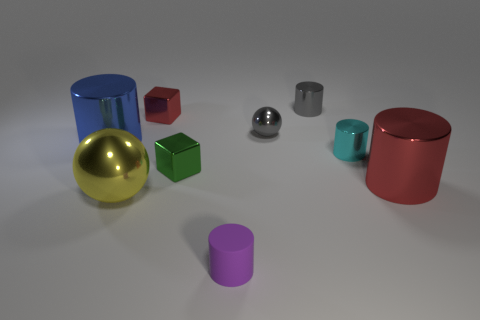There is a small thing that is right of the tiny gray cylinder; what is its material?
Your answer should be compact. Metal. What number of other objects have the same shape as the tiny red shiny object?
Your answer should be compact. 1. There is a red object that is to the right of the thing in front of the large yellow sphere; what is its material?
Make the answer very short. Metal. What is the shape of the small metal thing that is the same color as the tiny ball?
Offer a terse response. Cylinder. Are there any small balls that have the same material as the tiny red block?
Ensure brevity in your answer.  Yes. What shape is the tiny red object?
Your answer should be compact. Cube. How many cyan metallic cylinders are there?
Your response must be concise. 1. What color is the block behind the big shiny thing to the left of the big ball?
Provide a succinct answer. Red. The ball that is the same size as the red block is what color?
Ensure brevity in your answer.  Gray. Is there another sphere of the same color as the large ball?
Offer a terse response. No. 